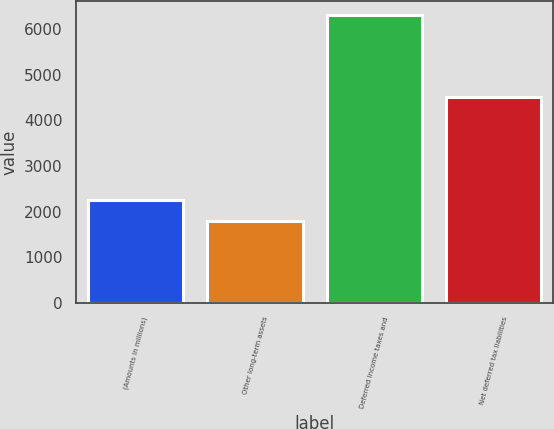Convert chart. <chart><loc_0><loc_0><loc_500><loc_500><bar_chart><fcel>(Amounts in millions)<fcel>Other long-term assets<fcel>Deferred income taxes and<fcel>Net deferred tax liabilities<nl><fcel>2246<fcel>1796<fcel>6296<fcel>4500<nl></chart> 